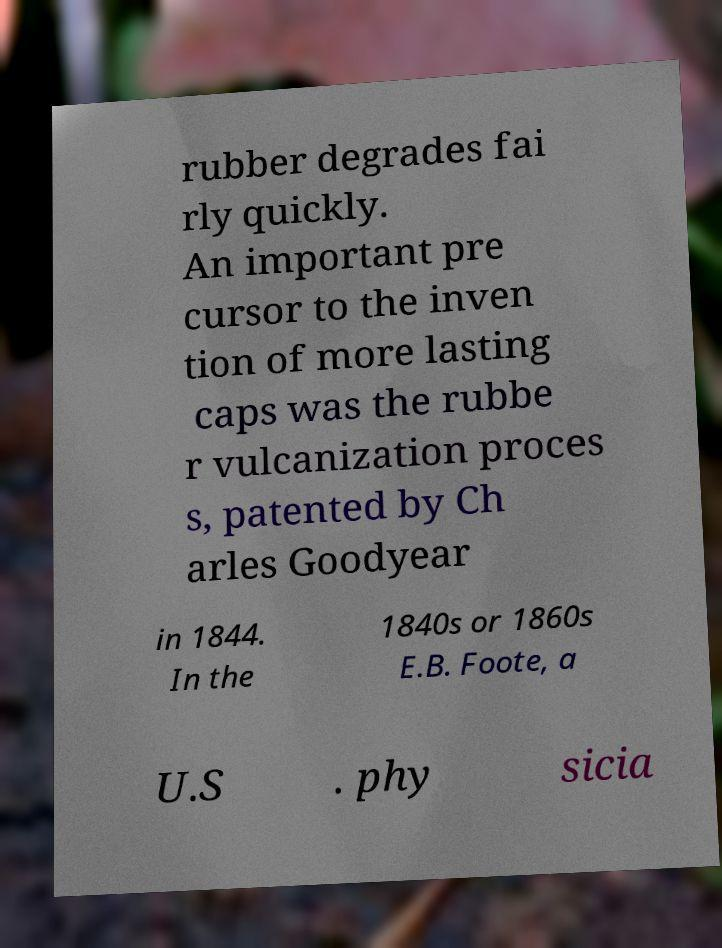Can you read and provide the text displayed in the image?This photo seems to have some interesting text. Can you extract and type it out for me? rubber degrades fai rly quickly. An important pre cursor to the inven tion of more lasting caps was the rubbe r vulcanization proces s, patented by Ch arles Goodyear in 1844. In the 1840s or 1860s E.B. Foote, a U.S . phy sicia 